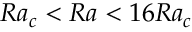Convert formula to latex. <formula><loc_0><loc_0><loc_500><loc_500>R a _ { c } < R a < 1 6 R a _ { c }</formula> 